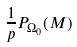Convert formula to latex. <formula><loc_0><loc_0><loc_500><loc_500>\frac { 1 } { p } P _ { \Omega _ { 0 } } ( M )</formula> 